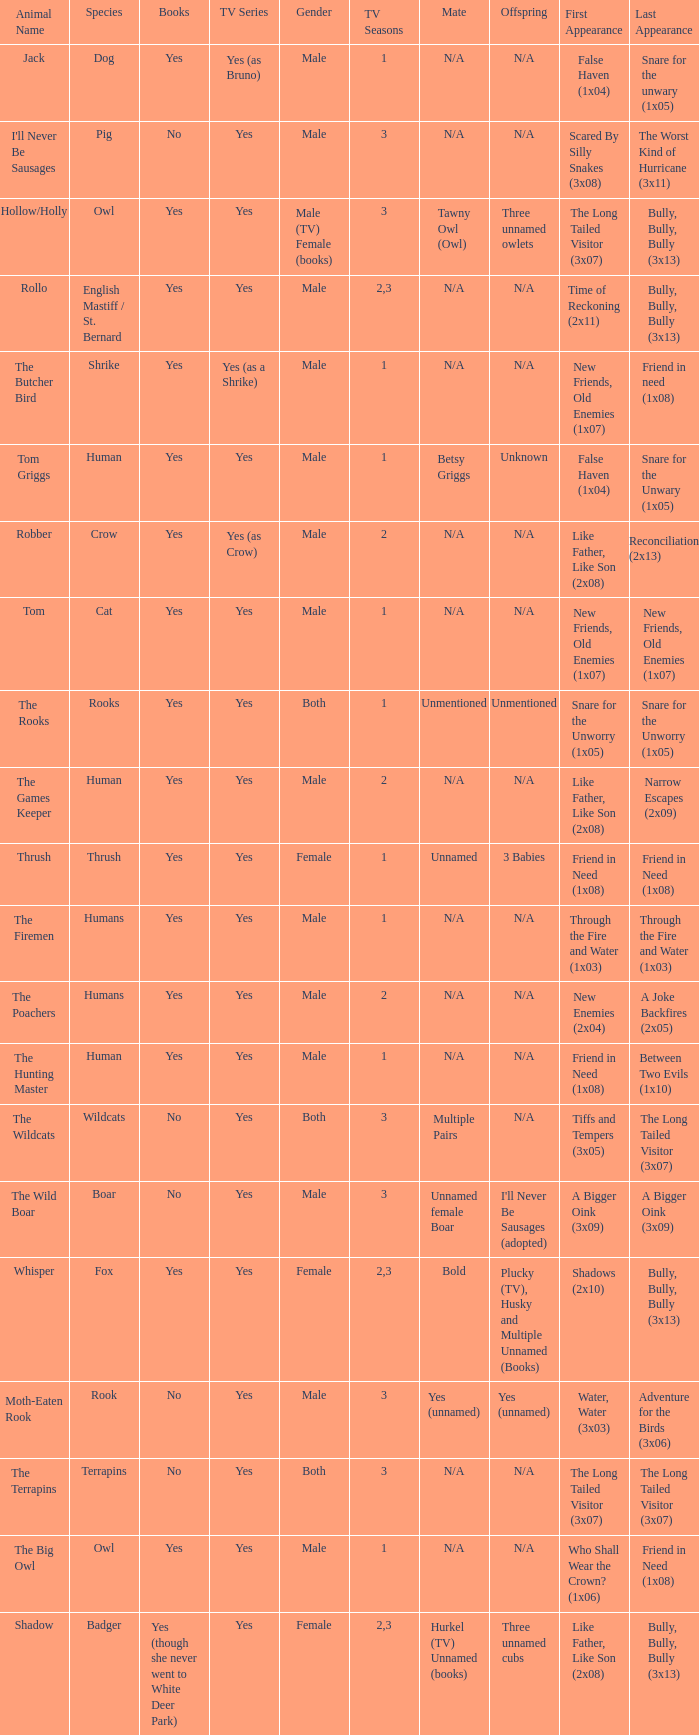Help me parse the entirety of this table. {'header': ['Animal Name', 'Species', 'Books', 'TV Series', 'Gender', 'TV Seasons', 'Mate', 'Offspring', 'First Appearance', 'Last Appearance'], 'rows': [['Jack', 'Dog', 'Yes', 'Yes (as Bruno)', 'Male', '1', 'N/A', 'N/A', 'False Haven (1x04)', 'Snare for the unwary (1x05)'], ["I'll Never Be Sausages", 'Pig', 'No', 'Yes', 'Male', '3', 'N/A', 'N/A', 'Scared By Silly Snakes (3x08)', 'The Worst Kind of Hurricane (3x11)'], ['Hollow/Holly', 'Owl', 'Yes', 'Yes', 'Male (TV) Female (books)', '3', 'Tawny Owl (Owl)', 'Three unnamed owlets', 'The Long Tailed Visitor (3x07)', 'Bully, Bully, Bully (3x13)'], ['Rollo', 'English Mastiff / St. Bernard', 'Yes', 'Yes', 'Male', '2,3', 'N/A', 'N/A', 'Time of Reckoning (2x11)', 'Bully, Bully, Bully (3x13)'], ['The Butcher Bird', 'Shrike', 'Yes', 'Yes (as a Shrike)', 'Male', '1', 'N/A', 'N/A', 'New Friends, Old Enemies (1x07)', 'Friend in need (1x08)'], ['Tom Griggs', 'Human', 'Yes', 'Yes', 'Male', '1', 'Betsy Griggs', 'Unknown', 'False Haven (1x04)', 'Snare for the Unwary (1x05)'], ['Robber', 'Crow', 'Yes', 'Yes (as Crow)', 'Male', '2', 'N/A', 'N/A', 'Like Father, Like Son (2x08)', 'Reconciliation (2x13)'], ['Tom', 'Cat', 'Yes', 'Yes', 'Male', '1', 'N/A', 'N/A', 'New Friends, Old Enemies (1x07)', 'New Friends, Old Enemies (1x07)'], ['The Rooks', 'Rooks', 'Yes', 'Yes', 'Both', '1', 'Unmentioned', 'Unmentioned', 'Snare for the Unworry (1x05)', 'Snare for the Unworry (1x05)'], ['The Games Keeper', 'Human', 'Yes', 'Yes', 'Male', '2', 'N/A', 'N/A', 'Like Father, Like Son (2x08)', 'Narrow Escapes (2x09)'], ['Thrush', 'Thrush', 'Yes', 'Yes', 'Female', '1', 'Unnamed', '3 Babies', 'Friend in Need (1x08)', 'Friend in Need (1x08)'], ['The Firemen', 'Humans', 'Yes', 'Yes', 'Male', '1', 'N/A', 'N/A', 'Through the Fire and Water (1x03)', 'Through the Fire and Water (1x03)'], ['The Poachers', 'Humans', 'Yes', 'Yes', 'Male', '2', 'N/A', 'N/A', 'New Enemies (2x04)', 'A Joke Backfires (2x05)'], ['The Hunting Master', 'Human', 'Yes', 'Yes', 'Male', '1', 'N/A', 'N/A', 'Friend in Need (1x08)', 'Between Two Evils (1x10)'], ['The Wildcats', 'Wildcats', 'No', 'Yes', 'Both', '3', 'Multiple Pairs', 'N/A', 'Tiffs and Tempers (3x05)', 'The Long Tailed Visitor (3x07)'], ['The Wild Boar', 'Boar', 'No', 'Yes', 'Male', '3', 'Unnamed female Boar', "I'll Never Be Sausages (adopted)", 'A Bigger Oink (3x09)', 'A Bigger Oink (3x09)'], ['Whisper', 'Fox', 'Yes', 'Yes', 'Female', '2,3', 'Bold', 'Plucky (TV), Husky and Multiple Unnamed (Books)', 'Shadows (2x10)', 'Bully, Bully, Bully (3x13)'], ['Moth-Eaten Rook', 'Rook', 'No', 'Yes', 'Male', '3', 'Yes (unnamed)', 'Yes (unnamed)', 'Water, Water (3x03)', 'Adventure for the Birds (3x06)'], ['The Terrapins', 'Terrapins', 'No', 'Yes', 'Both', '3', 'N/A', 'N/A', 'The Long Tailed Visitor (3x07)', 'The Long Tailed Visitor (3x07)'], ['The Big Owl', 'Owl', 'Yes', 'Yes', 'Male', '1', 'N/A', 'N/A', 'Who Shall Wear the Crown? (1x06)', 'Friend in Need (1x08)'], ['Shadow', 'Badger', 'Yes (though she never went to White Deer Park)', 'Yes', 'Female', '2,3', 'Hurkel (TV) Unnamed (books)', 'Three unnamed cubs', 'Like Father, Like Son (2x08)', 'Bully, Bully, Bully (3x13)']]} What show has a boar? Yes. 